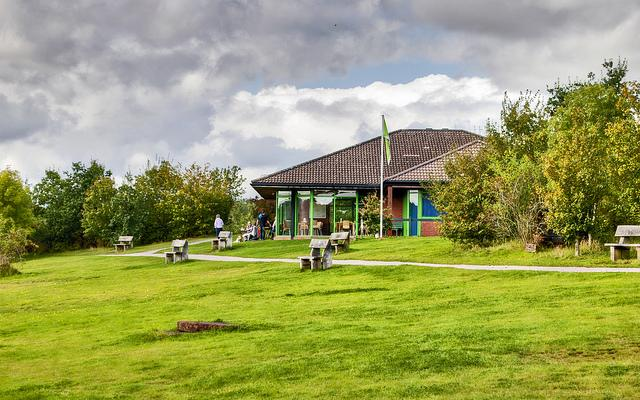What flowers might grow wild in this environment?

Choices:
A) roses
B) dhalias
C) dandelions
D) foxglove dandelions 